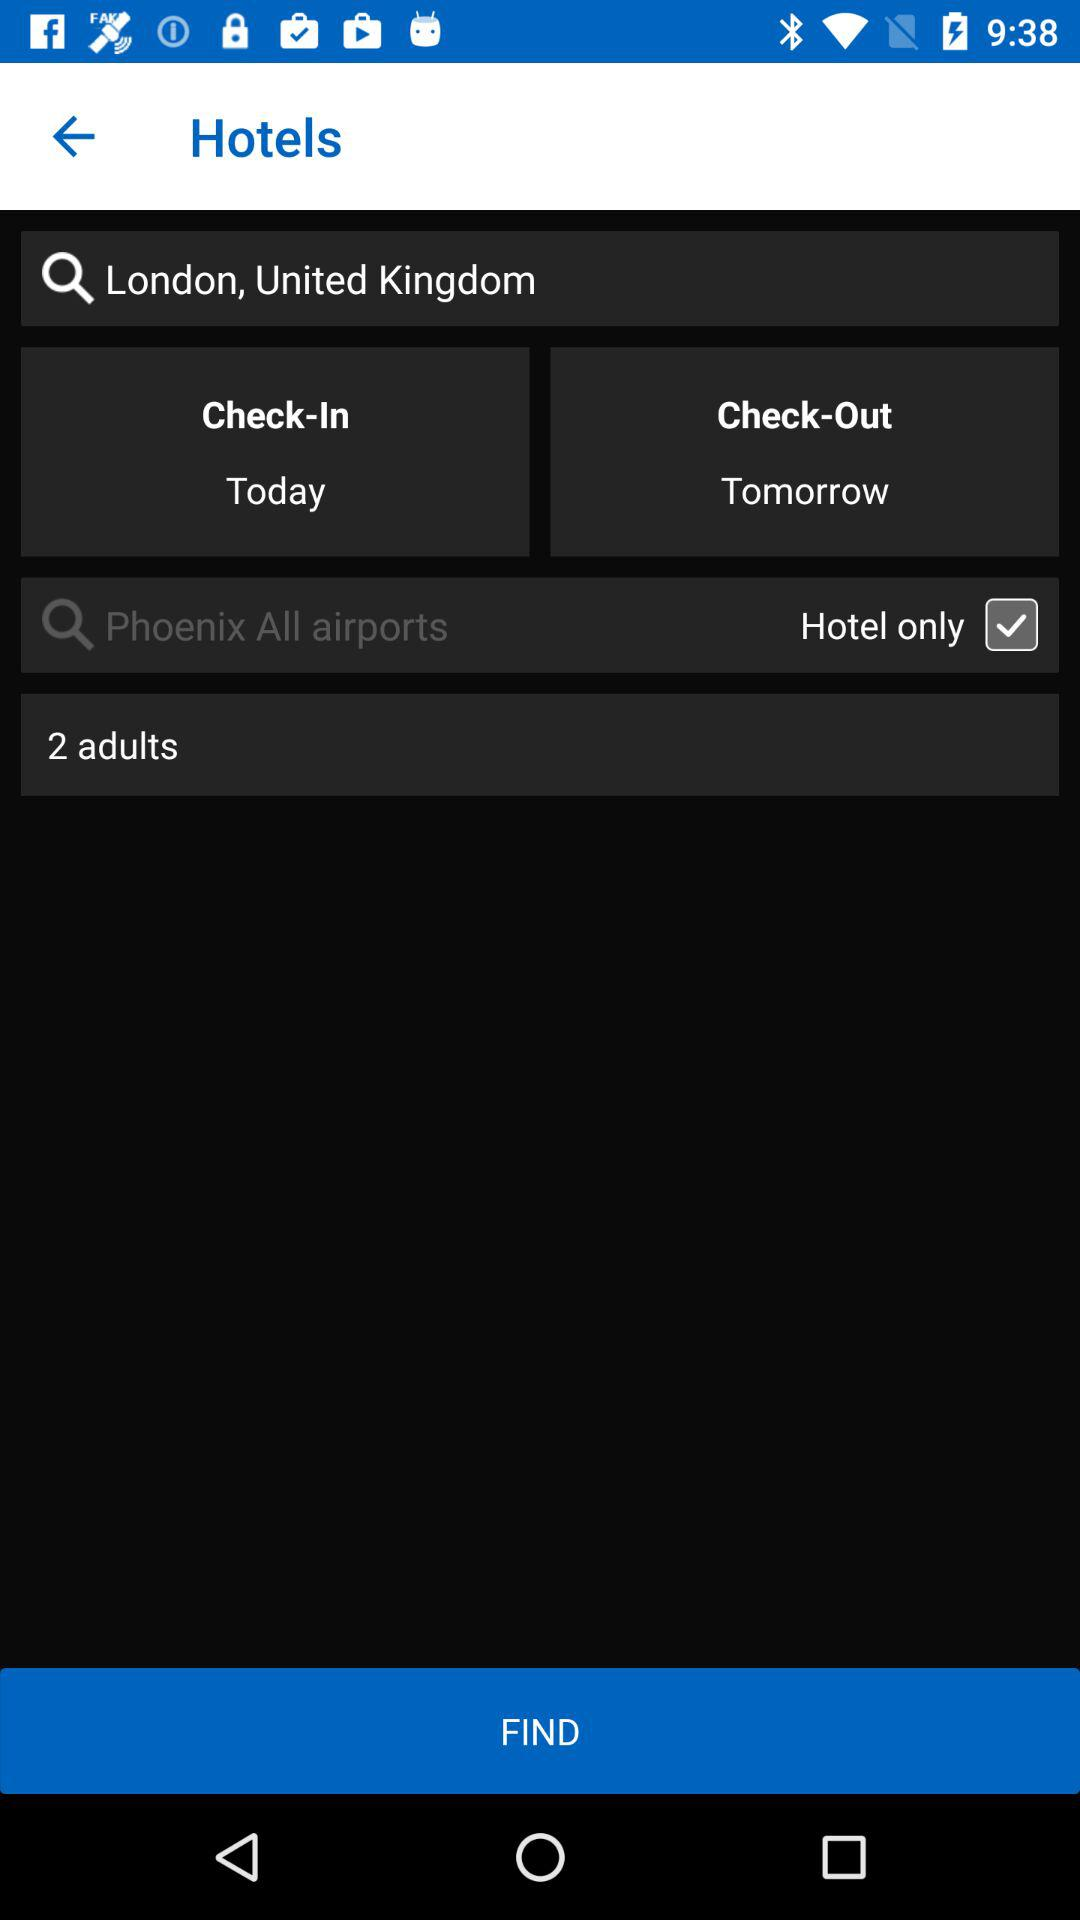What is the location of the hotel? The location of the hotel is London, United Kingdom. 